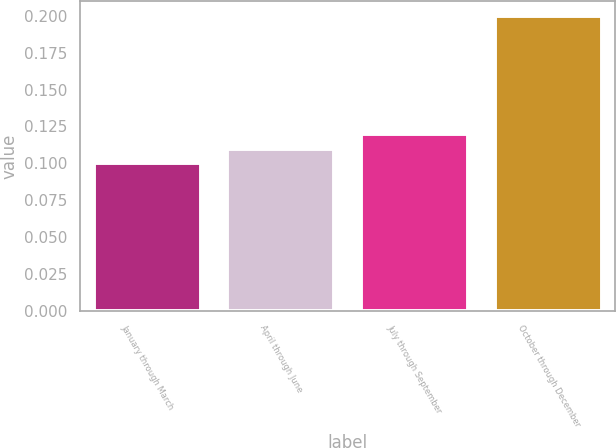Convert chart. <chart><loc_0><loc_0><loc_500><loc_500><bar_chart><fcel>January through March<fcel>April through June<fcel>July through September<fcel>October through December<nl><fcel>0.1<fcel>0.11<fcel>0.12<fcel>0.2<nl></chart> 